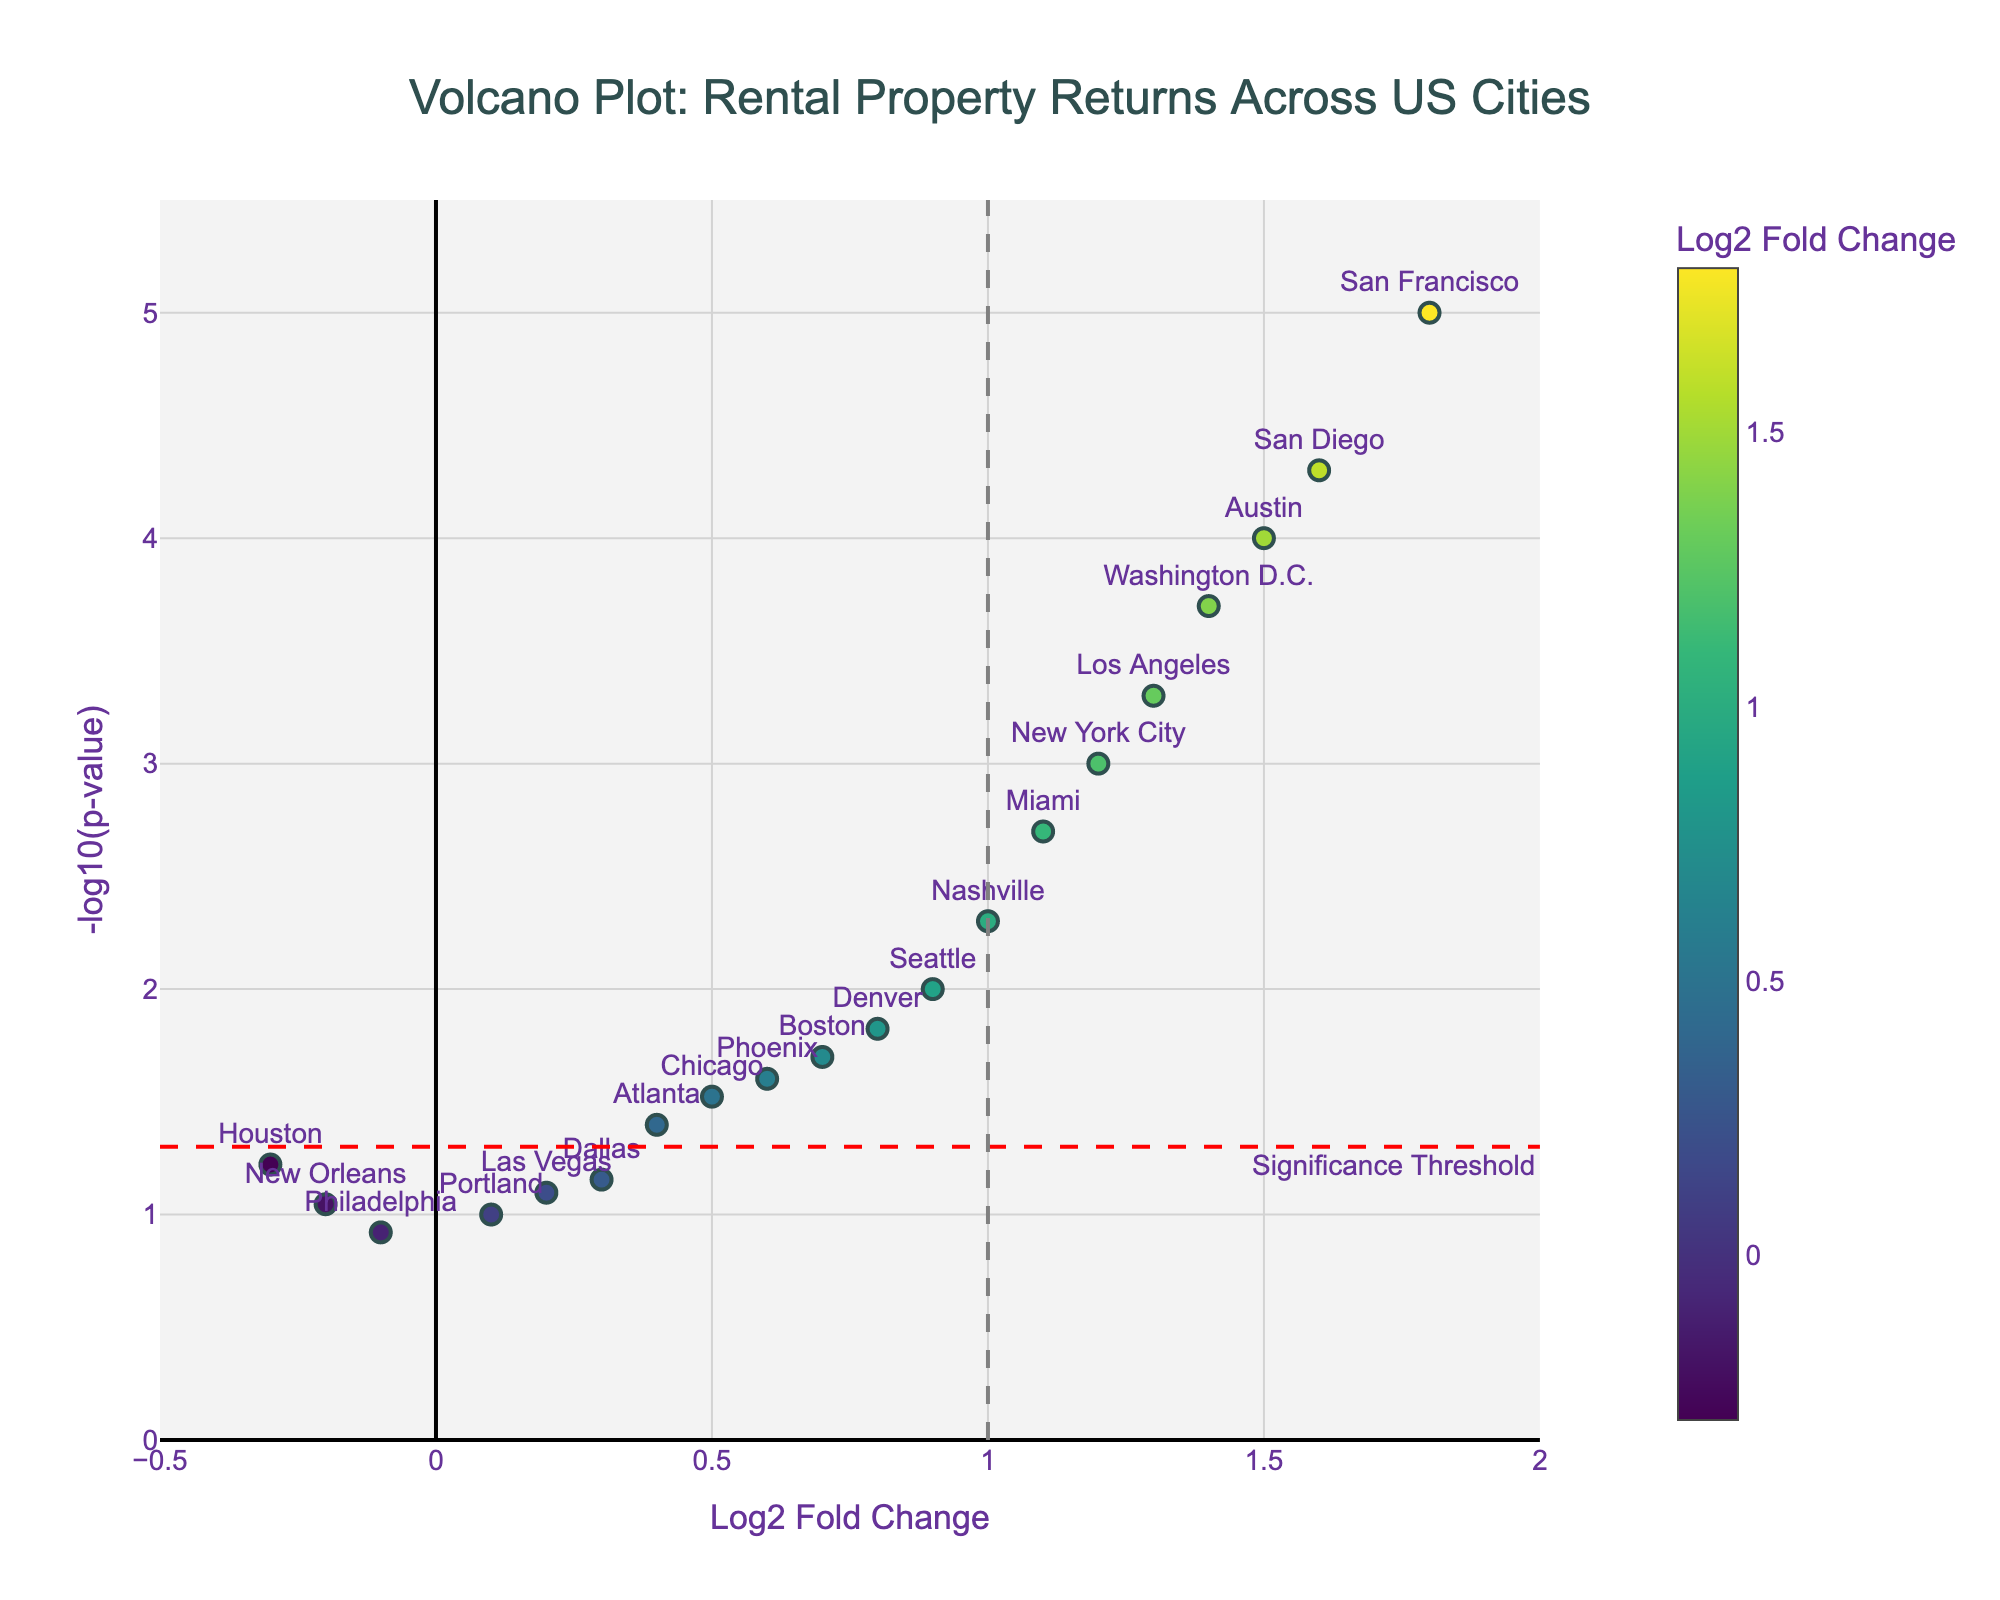What does the title of the plot indicate? The title "Volcano Plot: Rental Property Returns Across US Cities" indicates that the plot is comparing rental property returns in various US cities, highlighting differences in profitability.
Answer: Comparison of rental property returns in US cities What does the x-axis represent? The x-axis represents the Log2 Fold Change, which indicates how much the rental property returns have changed in a log scale.
Answer: Log2 Fold Change What does the y-axis represent? The y-axis represents the -log10(p-value), which shows the statistical significance of the changes in rental property returns.
Answer: -log10(p-value) Which city shows the highest Log2 Fold Change? The highest Log2 Fold Change is represented by the city farthest to the right on the x-axis. This city is San Francisco with a Log2 Fold Change of 1.8.
Answer: San Francisco Which city has the most statistically significant change in rental property returns? The most statistically significant change will be the city with the highest point on the y-axis. This city is San Francisco with a -log10(p-value) indicating a very low p-value of 0.00001.
Answer: San Francisco Which cities have a Log2 Fold Change greater than 1 and are also statistically significant? These cities will have markers to the right of the vertical line at x = 1 and above the horizontal line indicating the significance threshold. The cities are New York City, San Francisco, Miami, Austin, Los Angeles, Washington D.C., and San Diego.
Answer: New York City, San Francisco, Miami, Austin, Los Angeles, Washington D.C., San Diego Compare the statistical significance of rental returns between Miami and Seattle. Miami is statistically more significant as it is higher on the y-axis compared to Seattle, indicating a lower p-value. Miami has a p-value of 0.002, while Seattle has a p-value of 0.01.
Answer: Miami Which cities have a Log2 Fold Change close to zero but are not statistically significant? These cities have markers near the center along the x-axis and below the horizontal significance threshold. Cities like Portland (0.1), New Orleans (-0.2), and Philadelphia (-0.1) meet these criteria.
Answer: Portland, New Orleans, Philadelphia How many cities have a negative Log2 Fold Change? Cities with a negative Log2 Fold Change will have markers to the left of the origin on the x-axis. These cities are Houston (-0.3) and New Orleans (-0.2).
Answer: Two cities Identify cities with both high Log2 Fold Change and high statistical significance and provide the reasonable investment inference based on this information. Cities with both high Log2 Fold Change (far right on the x-axis) and high statistical significance (high on the y-axis) are likely profitable investment choices. These cities include San Francisco (1.8, 0.00001), Austin (1.5, 0.0001), Washington D.C. (1.4, 0.0002), Los Angeles (1.3, 0.0005), and San Diego (1.6, 0.00005).
Answer: San Francisco, Austin, Washington D.C., Los Angeles, San Diego 